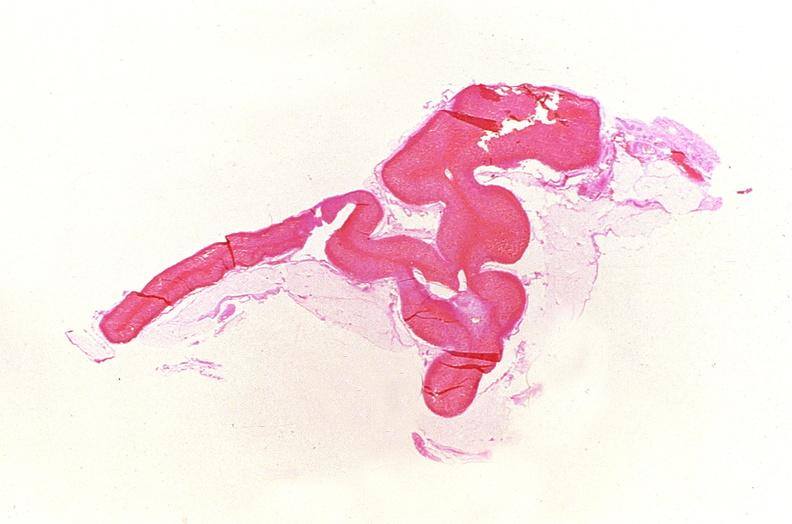where is this part in the figure?
Answer the question using a single word or phrase. Endocrine system 